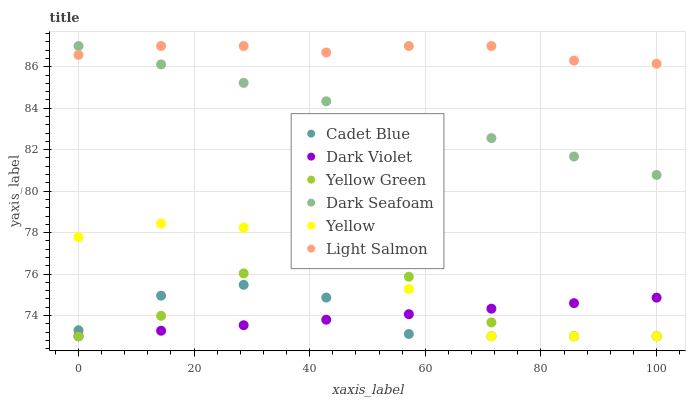Does Dark Violet have the minimum area under the curve?
Answer yes or no. Yes. Does Light Salmon have the maximum area under the curve?
Answer yes or no. Yes. Does Cadet Blue have the minimum area under the curve?
Answer yes or no. No. Does Cadet Blue have the maximum area under the curve?
Answer yes or no. No. Is Dark Violet the smoothest?
Answer yes or no. Yes. Is Yellow Green the roughest?
Answer yes or no. Yes. Is Cadet Blue the smoothest?
Answer yes or no. No. Is Cadet Blue the roughest?
Answer yes or no. No. Does Cadet Blue have the lowest value?
Answer yes or no. Yes. Does Dark Seafoam have the lowest value?
Answer yes or no. No. Does Dark Seafoam have the highest value?
Answer yes or no. Yes. Does Cadet Blue have the highest value?
Answer yes or no. No. Is Dark Violet less than Light Salmon?
Answer yes or no. Yes. Is Light Salmon greater than Cadet Blue?
Answer yes or no. Yes. Does Yellow Green intersect Dark Violet?
Answer yes or no. Yes. Is Yellow Green less than Dark Violet?
Answer yes or no. No. Is Yellow Green greater than Dark Violet?
Answer yes or no. No. Does Dark Violet intersect Light Salmon?
Answer yes or no. No. 